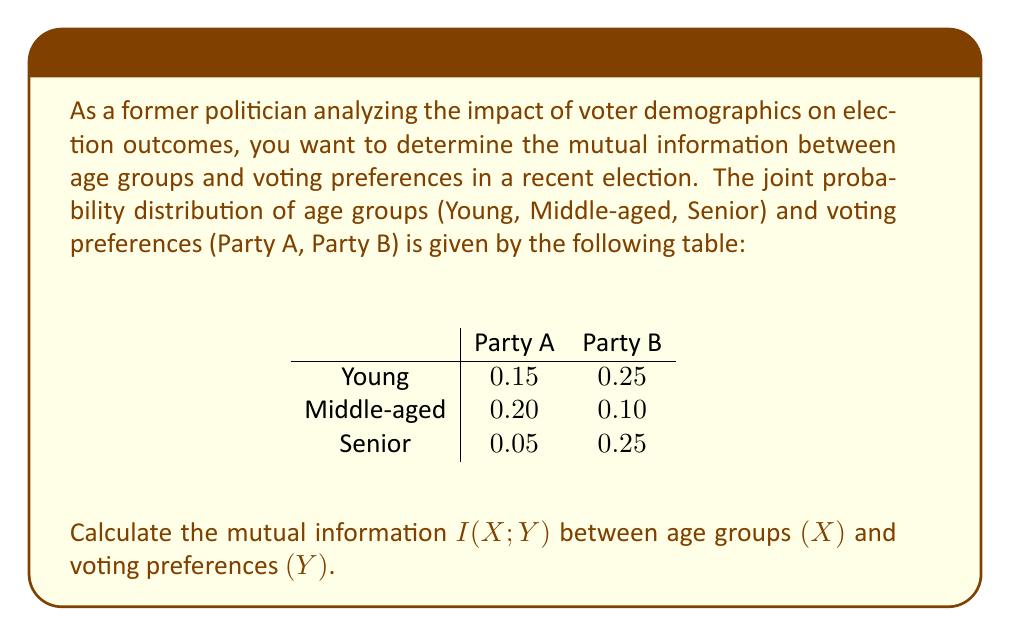Teach me how to tackle this problem. To calculate the mutual information $I(X;Y)$, we'll follow these steps:

1) First, we need to calculate the marginal probabilities:

   $P(X = \text{Young}) = 0.15 + 0.25 = 0.40$
   $P(X = \text{Middle-aged}) = 0.20 + 0.10 = 0.30$
   $P(X = \text{Senior}) = 0.05 + 0.25 = 0.30$

   $P(Y = \text{Party A}) = 0.15 + 0.20 + 0.05 = 0.40$
   $P(Y = \text{Party B}) = 0.25 + 0.10 + 0.25 = 0.60$

2) The mutual information is given by:

   $$I(X;Y) = \sum_{x \in X} \sum_{y \in Y} P(x,y) \log_2 \frac{P(x,y)}{P(x)P(y)}$$

3) Let's calculate each term:

   For Young, Party A: $0.15 \log_2 \frac{0.15}{0.40 \cdot 0.40} = 0.15 \log_2 0.9375 = -0.0137$
   For Young, Party B: $0.25 \log_2 \frac{0.25}{0.40 \cdot 0.60} = 0.25 \log_2 1.0417 = 0.0025$
   For Middle-aged, Party A: $0.20 \log_2 \frac{0.20}{0.30 \cdot 0.40} = 0.20 \log_2 1.6667 = 0.0918$
   For Middle-aged, Party B: $0.10 \log_2 \frac{0.10}{0.30 \cdot 0.60} = 0.10 \log_2 0.5556 = -0.0575$
   For Senior, Party A: $0.05 \log_2 \frac{0.05}{0.30 \cdot 0.40} = 0.05 \log_2 0.4167 = -0.0631$
   For Senior, Party B: $0.25 \log_2 \frac{0.25}{0.30 \cdot 0.60} = 0.25 \log_2 1.3889 = 0.0802$

4) Sum all these terms:

   $I(X;Y) = -0.0137 + 0.0025 + 0.0918 - 0.0575 - 0.0631 + 0.0802 = 0.0402$ bits

This positive mutual information indicates that there is some dependence between age groups and voting preferences, which could be valuable information for a former politician analyzing voting patterns.
Answer: The mutual information $I(X;Y)$ between age groups and voting preferences is approximately 0.0402 bits. 